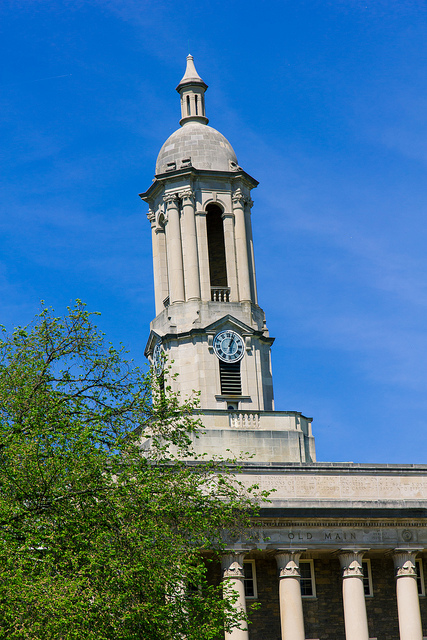<image>Is it legal to park next to this object? It is ambiguous whether it is legal to park next to this object. What religious symbol is on top of the building? There is no specific religious symbol seen on top of the building. It could be a 'steeple', 'spire', or 'cross'. Is it legal to park next to this object? I am not sure if it is legal to park next to this object. It can be seen both yes and no. What religious symbol is on top of the building? It is ambiguous what religious symbol is on top of the building. It can be seen 'mormon', 'steeple', 'spire', 'angel', 'christian', or 'cross'. 